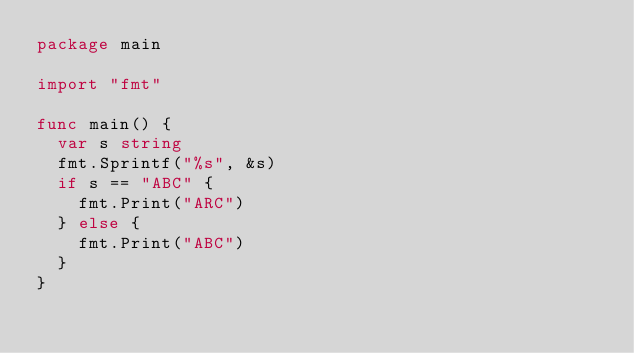<code> <loc_0><loc_0><loc_500><loc_500><_Go_>package main

import "fmt"

func main() {
	var s string
	fmt.Sprintf("%s", &s)
	if s == "ABC" {
		fmt.Print("ARC")
	} else {
		fmt.Print("ABC")
	}
}
</code> 